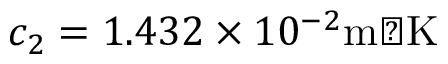Convert formula to latex. <formula><loc_0><loc_0><loc_500><loc_500>c _ { 2 } = 1 . 4 3 2 \times 1 0 ^ { - 2 } { m K }</formula> 